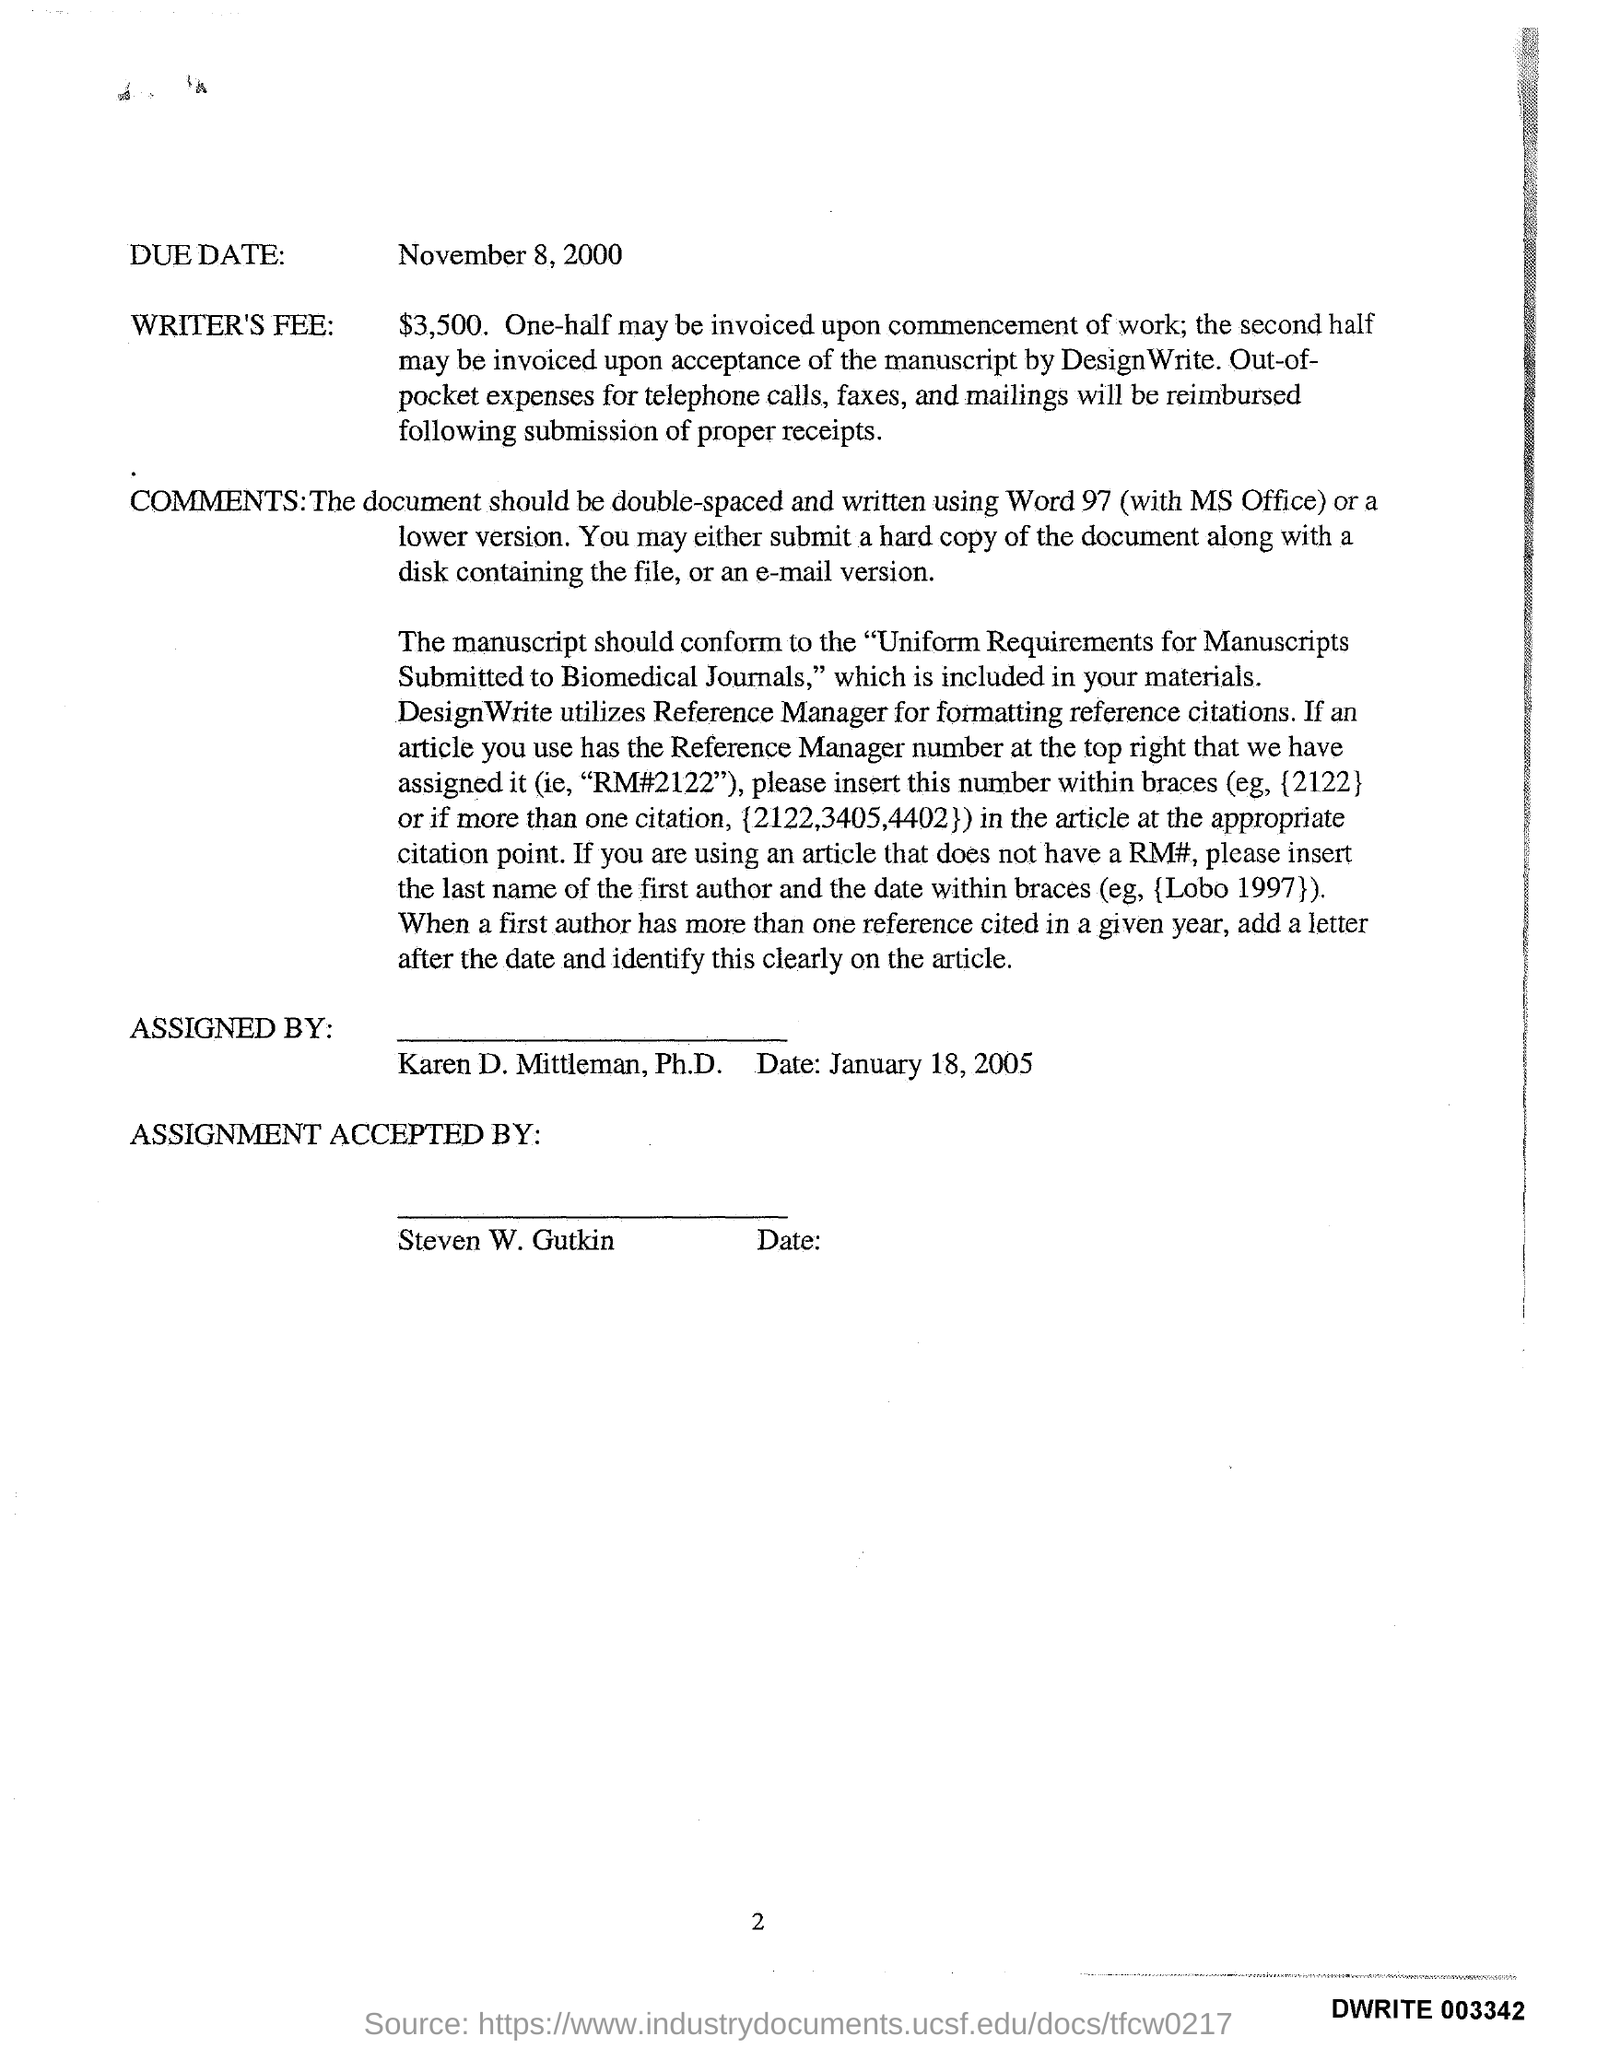What is writers fee?
Your response must be concise. $3,500. 